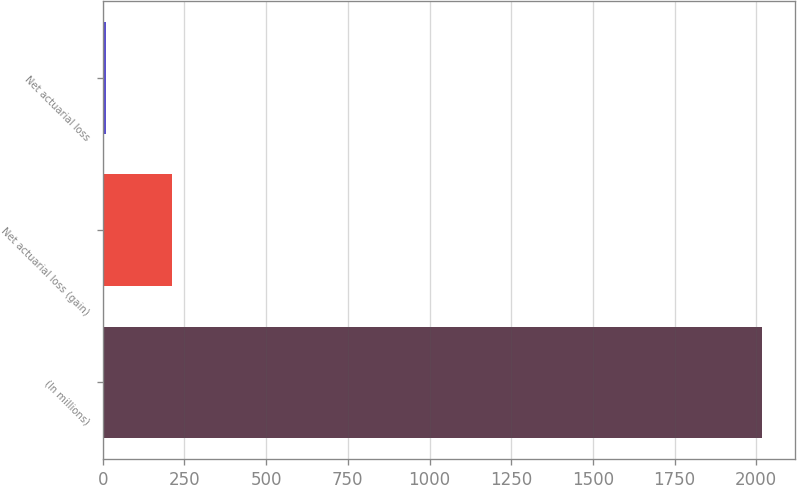<chart> <loc_0><loc_0><loc_500><loc_500><bar_chart><fcel>(In millions)<fcel>Net actuarial loss (gain)<fcel>Net actuarial loss<nl><fcel>2017<fcel>211.6<fcel>11<nl></chart> 